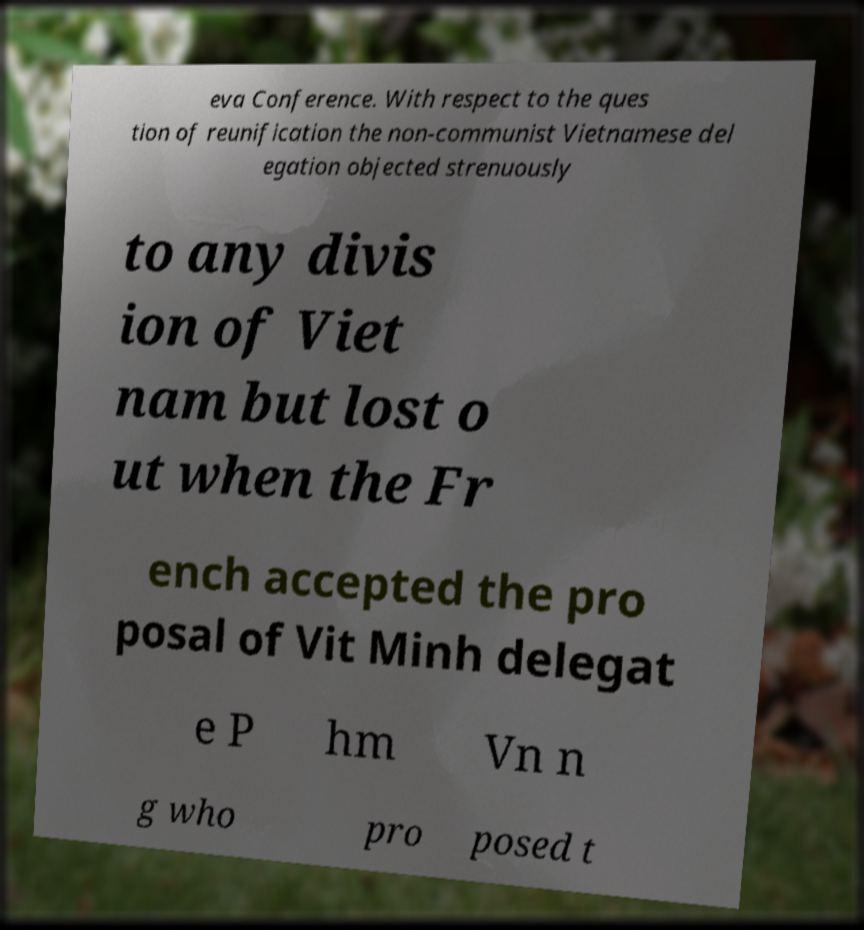Can you accurately transcribe the text from the provided image for me? eva Conference. With respect to the ques tion of reunification the non-communist Vietnamese del egation objected strenuously to any divis ion of Viet nam but lost o ut when the Fr ench accepted the pro posal of Vit Minh delegat e P hm Vn n g who pro posed t 